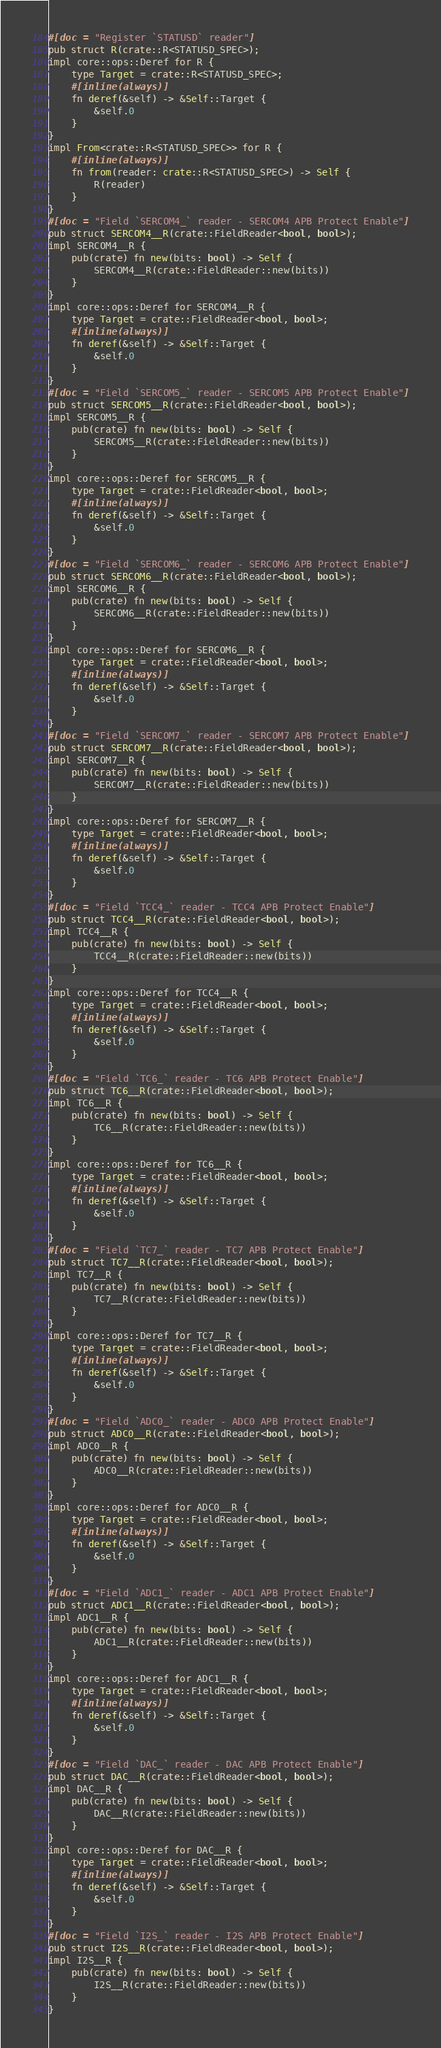Convert code to text. <code><loc_0><loc_0><loc_500><loc_500><_Rust_>#[doc = "Register `STATUSD` reader"]
pub struct R(crate::R<STATUSD_SPEC>);
impl core::ops::Deref for R {
    type Target = crate::R<STATUSD_SPEC>;
    #[inline(always)]
    fn deref(&self) -> &Self::Target {
        &self.0
    }
}
impl From<crate::R<STATUSD_SPEC>> for R {
    #[inline(always)]
    fn from(reader: crate::R<STATUSD_SPEC>) -> Self {
        R(reader)
    }
}
#[doc = "Field `SERCOM4_` reader - SERCOM4 APB Protect Enable"]
pub struct SERCOM4__R(crate::FieldReader<bool, bool>);
impl SERCOM4__R {
    pub(crate) fn new(bits: bool) -> Self {
        SERCOM4__R(crate::FieldReader::new(bits))
    }
}
impl core::ops::Deref for SERCOM4__R {
    type Target = crate::FieldReader<bool, bool>;
    #[inline(always)]
    fn deref(&self) -> &Self::Target {
        &self.0
    }
}
#[doc = "Field `SERCOM5_` reader - SERCOM5 APB Protect Enable"]
pub struct SERCOM5__R(crate::FieldReader<bool, bool>);
impl SERCOM5__R {
    pub(crate) fn new(bits: bool) -> Self {
        SERCOM5__R(crate::FieldReader::new(bits))
    }
}
impl core::ops::Deref for SERCOM5__R {
    type Target = crate::FieldReader<bool, bool>;
    #[inline(always)]
    fn deref(&self) -> &Self::Target {
        &self.0
    }
}
#[doc = "Field `SERCOM6_` reader - SERCOM6 APB Protect Enable"]
pub struct SERCOM6__R(crate::FieldReader<bool, bool>);
impl SERCOM6__R {
    pub(crate) fn new(bits: bool) -> Self {
        SERCOM6__R(crate::FieldReader::new(bits))
    }
}
impl core::ops::Deref for SERCOM6__R {
    type Target = crate::FieldReader<bool, bool>;
    #[inline(always)]
    fn deref(&self) -> &Self::Target {
        &self.0
    }
}
#[doc = "Field `SERCOM7_` reader - SERCOM7 APB Protect Enable"]
pub struct SERCOM7__R(crate::FieldReader<bool, bool>);
impl SERCOM7__R {
    pub(crate) fn new(bits: bool) -> Self {
        SERCOM7__R(crate::FieldReader::new(bits))
    }
}
impl core::ops::Deref for SERCOM7__R {
    type Target = crate::FieldReader<bool, bool>;
    #[inline(always)]
    fn deref(&self) -> &Self::Target {
        &self.0
    }
}
#[doc = "Field `TCC4_` reader - TCC4 APB Protect Enable"]
pub struct TCC4__R(crate::FieldReader<bool, bool>);
impl TCC4__R {
    pub(crate) fn new(bits: bool) -> Self {
        TCC4__R(crate::FieldReader::new(bits))
    }
}
impl core::ops::Deref for TCC4__R {
    type Target = crate::FieldReader<bool, bool>;
    #[inline(always)]
    fn deref(&self) -> &Self::Target {
        &self.0
    }
}
#[doc = "Field `TC6_` reader - TC6 APB Protect Enable"]
pub struct TC6__R(crate::FieldReader<bool, bool>);
impl TC6__R {
    pub(crate) fn new(bits: bool) -> Self {
        TC6__R(crate::FieldReader::new(bits))
    }
}
impl core::ops::Deref for TC6__R {
    type Target = crate::FieldReader<bool, bool>;
    #[inline(always)]
    fn deref(&self) -> &Self::Target {
        &self.0
    }
}
#[doc = "Field `TC7_` reader - TC7 APB Protect Enable"]
pub struct TC7__R(crate::FieldReader<bool, bool>);
impl TC7__R {
    pub(crate) fn new(bits: bool) -> Self {
        TC7__R(crate::FieldReader::new(bits))
    }
}
impl core::ops::Deref for TC7__R {
    type Target = crate::FieldReader<bool, bool>;
    #[inline(always)]
    fn deref(&self) -> &Self::Target {
        &self.0
    }
}
#[doc = "Field `ADC0_` reader - ADC0 APB Protect Enable"]
pub struct ADC0__R(crate::FieldReader<bool, bool>);
impl ADC0__R {
    pub(crate) fn new(bits: bool) -> Self {
        ADC0__R(crate::FieldReader::new(bits))
    }
}
impl core::ops::Deref for ADC0__R {
    type Target = crate::FieldReader<bool, bool>;
    #[inline(always)]
    fn deref(&self) -> &Self::Target {
        &self.0
    }
}
#[doc = "Field `ADC1_` reader - ADC1 APB Protect Enable"]
pub struct ADC1__R(crate::FieldReader<bool, bool>);
impl ADC1__R {
    pub(crate) fn new(bits: bool) -> Self {
        ADC1__R(crate::FieldReader::new(bits))
    }
}
impl core::ops::Deref for ADC1__R {
    type Target = crate::FieldReader<bool, bool>;
    #[inline(always)]
    fn deref(&self) -> &Self::Target {
        &self.0
    }
}
#[doc = "Field `DAC_` reader - DAC APB Protect Enable"]
pub struct DAC__R(crate::FieldReader<bool, bool>);
impl DAC__R {
    pub(crate) fn new(bits: bool) -> Self {
        DAC__R(crate::FieldReader::new(bits))
    }
}
impl core::ops::Deref for DAC__R {
    type Target = crate::FieldReader<bool, bool>;
    #[inline(always)]
    fn deref(&self) -> &Self::Target {
        &self.0
    }
}
#[doc = "Field `I2S_` reader - I2S APB Protect Enable"]
pub struct I2S__R(crate::FieldReader<bool, bool>);
impl I2S__R {
    pub(crate) fn new(bits: bool) -> Self {
        I2S__R(crate::FieldReader::new(bits))
    }
}</code> 